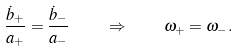Convert formula to latex. <formula><loc_0><loc_0><loc_500><loc_500>\frac { \dot { b } _ { + } } { a _ { + } } = \frac { \dot { b } _ { - } } { a _ { - } } \quad \Rightarrow \quad \omega _ { + } = \omega _ { - } .</formula> 